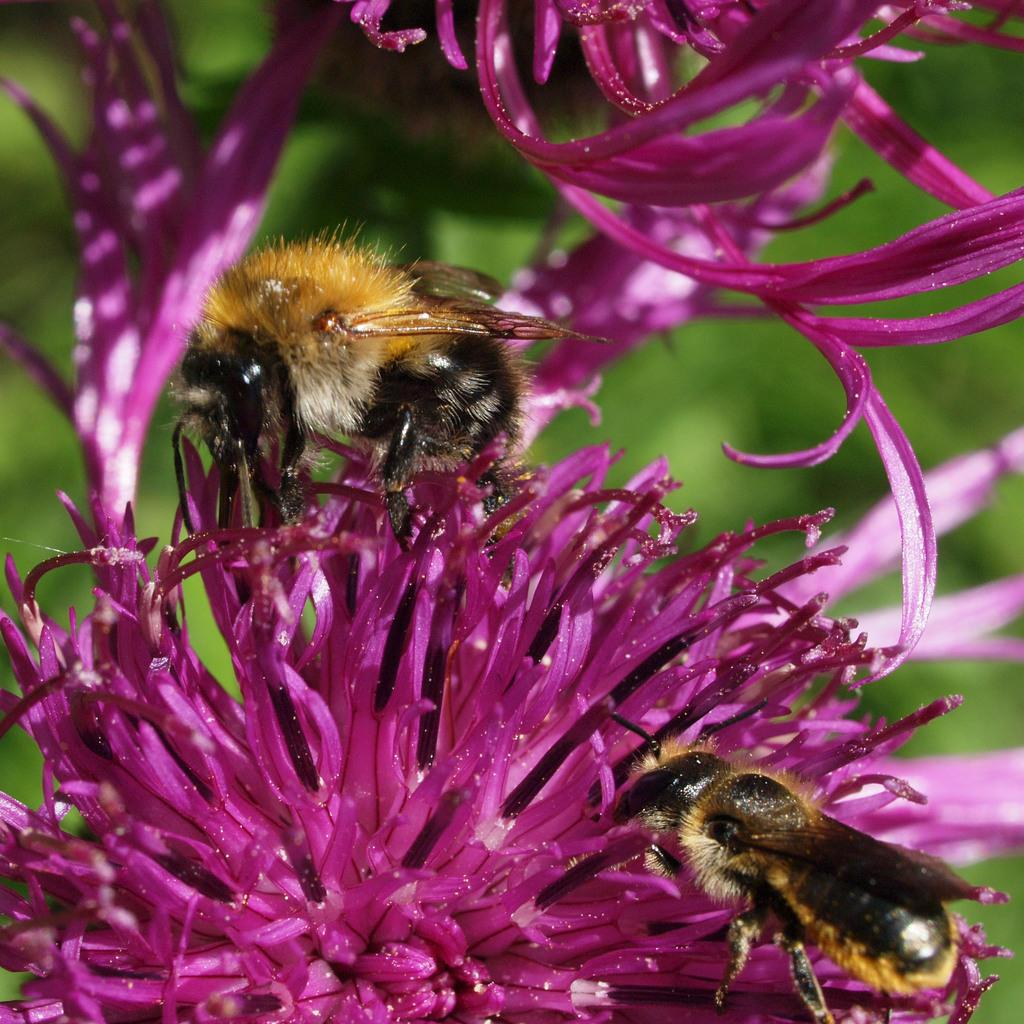What type of living organisms can be seen in the image? There are flowers and insects in the image. What are the insects doing in the image? The insects are present on the flowers. How would you describe the background of the image? The background of the image appears green and blurry. What type of family gathering is taking place in the image? There is no family gathering present in the image; it features flowers and insects. How much salt is visible in the image? There is no salt present in the image. 